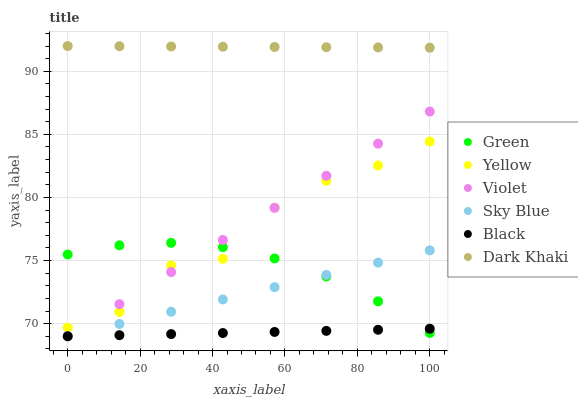Does Black have the minimum area under the curve?
Answer yes or no. Yes. Does Dark Khaki have the maximum area under the curve?
Answer yes or no. Yes. Does Green have the minimum area under the curve?
Answer yes or no. No. Does Green have the maximum area under the curve?
Answer yes or no. No. Is Sky Blue the smoothest?
Answer yes or no. Yes. Is Yellow the roughest?
Answer yes or no. Yes. Is Dark Khaki the smoothest?
Answer yes or no. No. Is Dark Khaki the roughest?
Answer yes or no. No. Does Black have the lowest value?
Answer yes or no. Yes. Does Green have the lowest value?
Answer yes or no. No. Does Dark Khaki have the highest value?
Answer yes or no. Yes. Does Green have the highest value?
Answer yes or no. No. Is Black less than Yellow?
Answer yes or no. Yes. Is Yellow greater than Black?
Answer yes or no. Yes. Does Sky Blue intersect Violet?
Answer yes or no. Yes. Is Sky Blue less than Violet?
Answer yes or no. No. Is Sky Blue greater than Violet?
Answer yes or no. No. Does Black intersect Yellow?
Answer yes or no. No. 